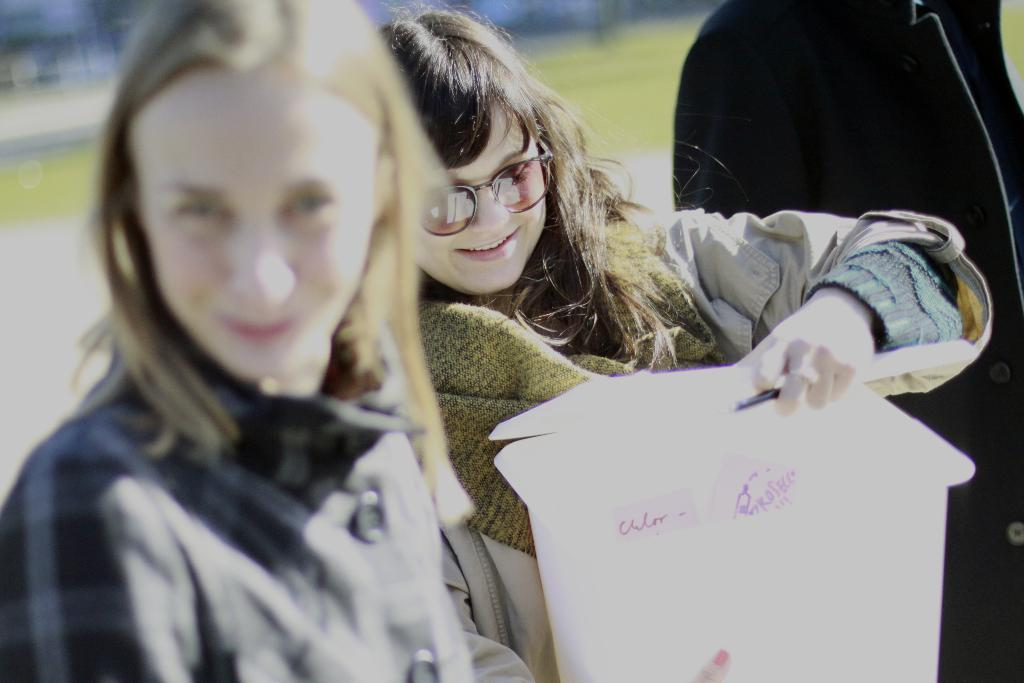What is the main subject of the image? The main subject of the image is a woman. What is the woman wearing in the image? The woman is wearing sunglasses in the image. What is the woman holding in the image? The woman is holding a paper bag in the image. Can you describe the person standing in the image? There is a human standing in the image, and it is the woman. What type of ground surface is visible in the image? Grass is visible on the ground in the image. What type of apparel is the woman suggesting in the image? There is no indication in the image that the woman is suggesting any apparel. What is the price of the sunglasses the woman is wearing in the image? The price of the sunglasses is not visible or mentioned in the image. 